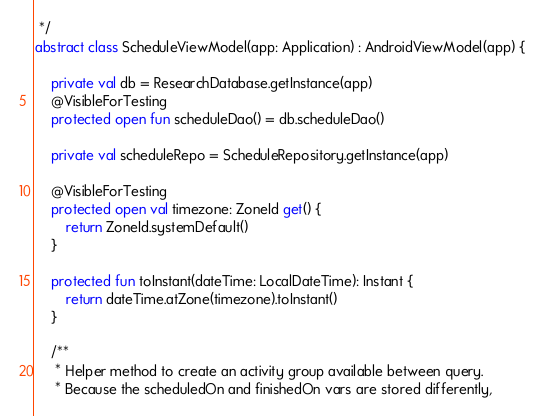<code> <loc_0><loc_0><loc_500><loc_500><_Kotlin_> */
abstract class ScheduleViewModel(app: Application) : AndroidViewModel(app) {

    private val db = ResearchDatabase.getInstance(app)
    @VisibleForTesting
    protected open fun scheduleDao() = db.scheduleDao()

    private val scheduleRepo = ScheduleRepository.getInstance(app)

    @VisibleForTesting
    protected open val timezone: ZoneId get() {
        return ZoneId.systemDefault()
    }

    protected fun toInstant(dateTime: LocalDateTime): Instant {
        return dateTime.atZone(timezone).toInstant()
    }

    /**
     * Helper method to create an activity group available between query.
     * Because the scheduledOn and finishedOn vars are stored differently,</code> 